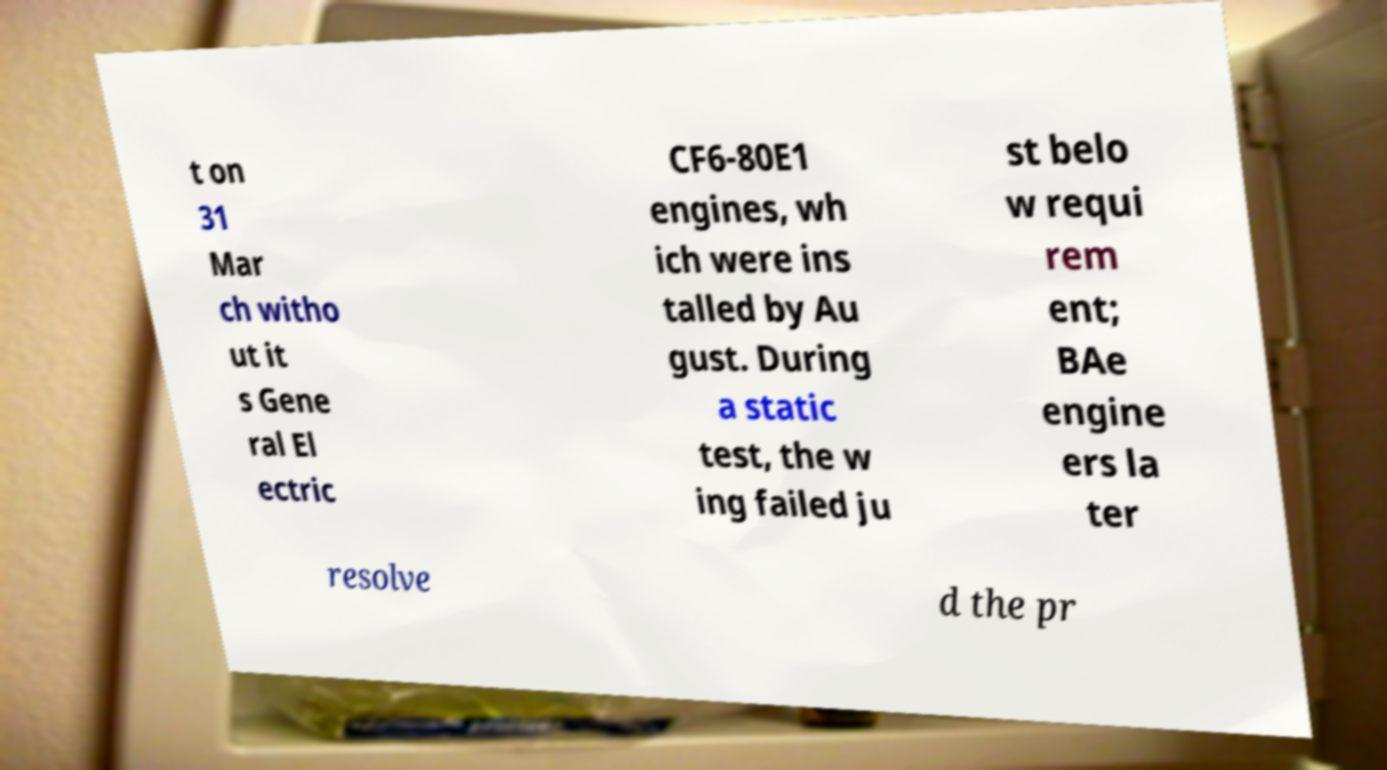Please identify and transcribe the text found in this image. t on 31 Mar ch witho ut it s Gene ral El ectric CF6-80E1 engines, wh ich were ins talled by Au gust. During a static test, the w ing failed ju st belo w requi rem ent; BAe engine ers la ter resolve d the pr 